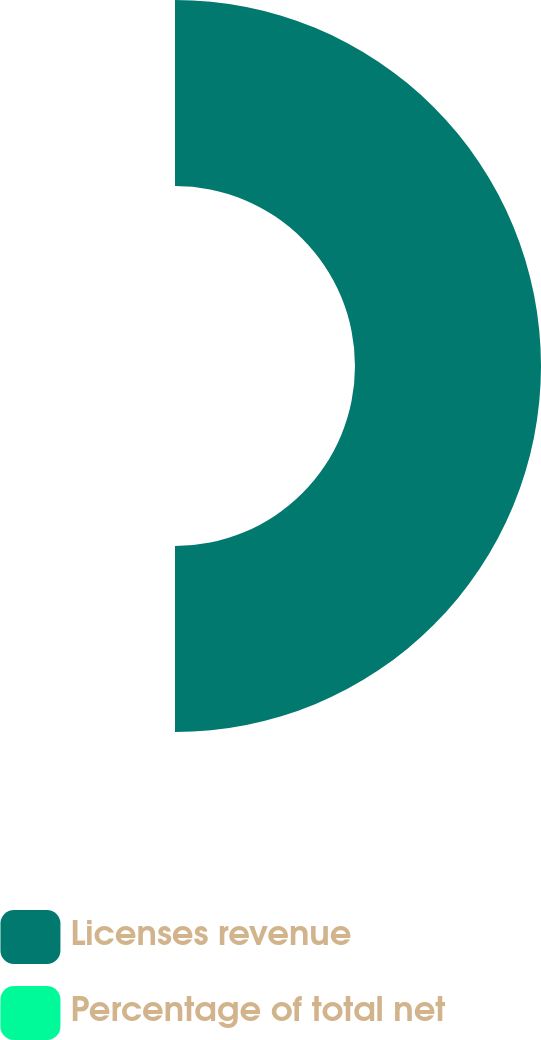Convert chart. <chart><loc_0><loc_0><loc_500><loc_500><pie_chart><fcel>Licenses revenue<fcel>Percentage of total net<nl><fcel>100.0%<fcel>0.0%<nl></chart> 